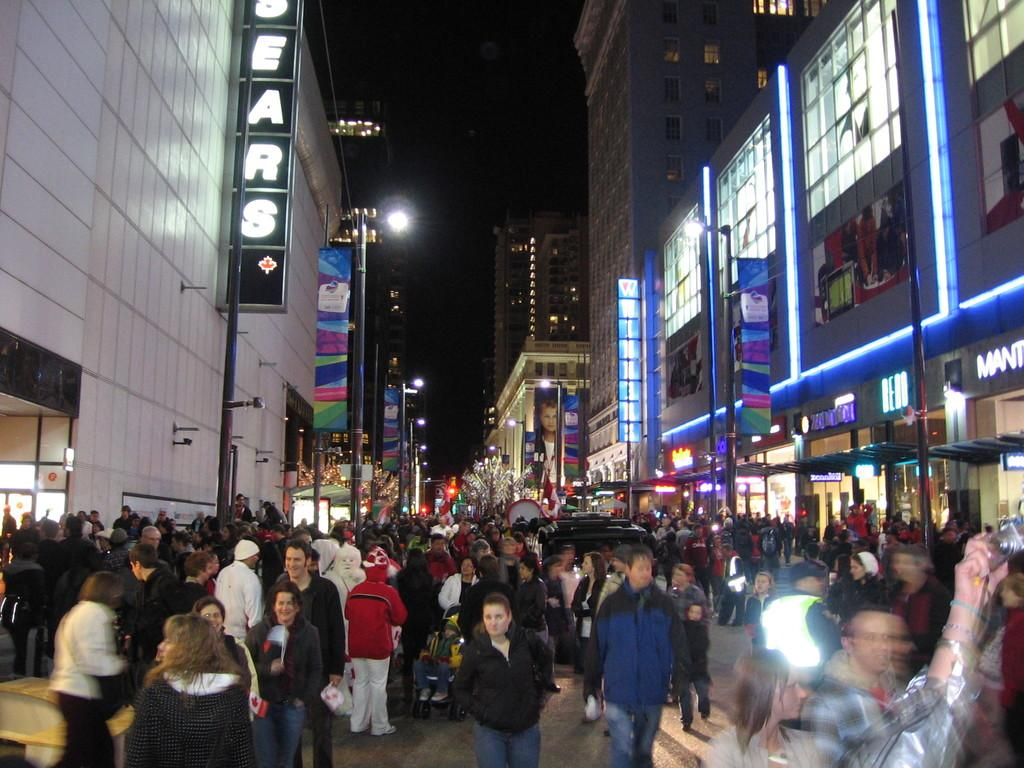How many people are visible in the image? There are many people in the image. What can be seen in the background of the image? There are buildings with lights in the image. Where are the buildings located in relation to the image? The buildings are on either side of the image. What is present on the left side of the image? There is a board on the left side of the image. What color is the hair of the person in the middle of the image? There is no person in the middle of the image, and no hair is visible in the image. What is the person using to write on the board? There is no person present in the image, and no writing instrument is visible. 